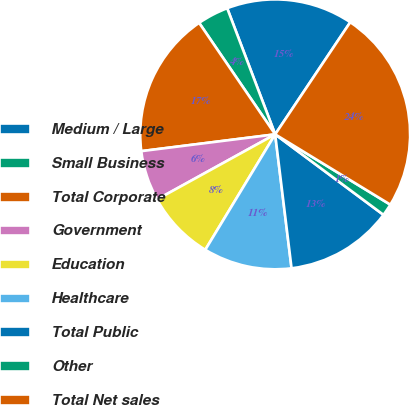Convert chart. <chart><loc_0><loc_0><loc_500><loc_500><pie_chart><fcel>Medium / Large<fcel>Small Business<fcel>Total Corporate<fcel>Government<fcel>Education<fcel>Healthcare<fcel>Total Public<fcel>Other<fcel>Total Net sales<nl><fcel>15.18%<fcel>3.74%<fcel>17.46%<fcel>6.03%<fcel>8.32%<fcel>10.6%<fcel>12.89%<fcel>1.45%<fcel>24.33%<nl></chart> 